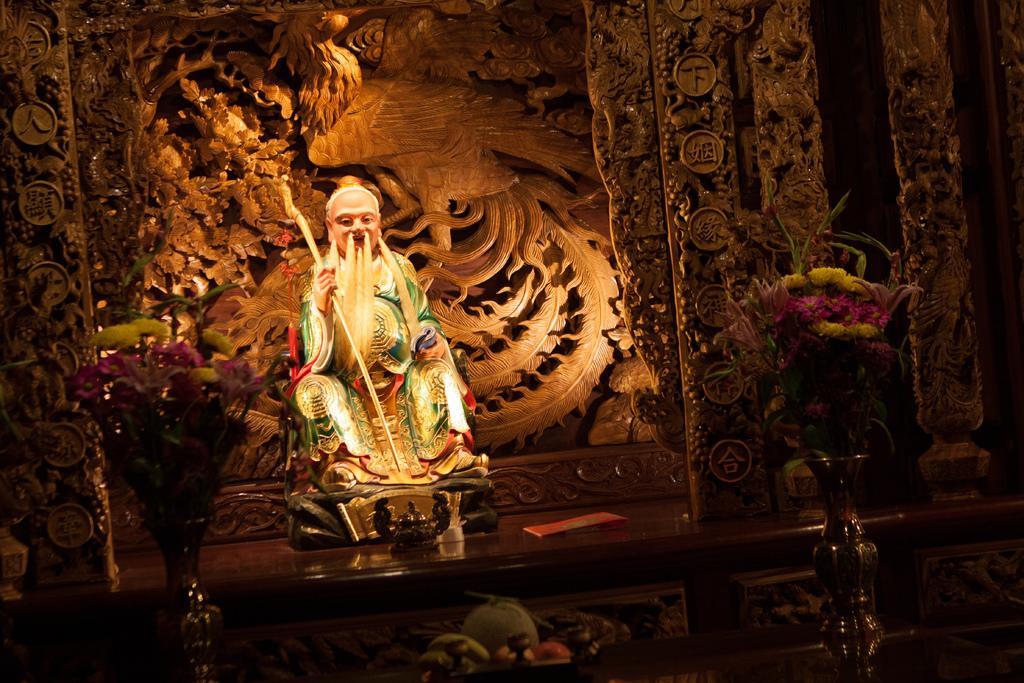Could you give a brief overview of what you see in this image? In this picture I can see there is an idol and there is some sculpture in the backdrop and there are few flowers at right side, there are fruits at the bottom of the image. The rest of the image is a bit dark. 